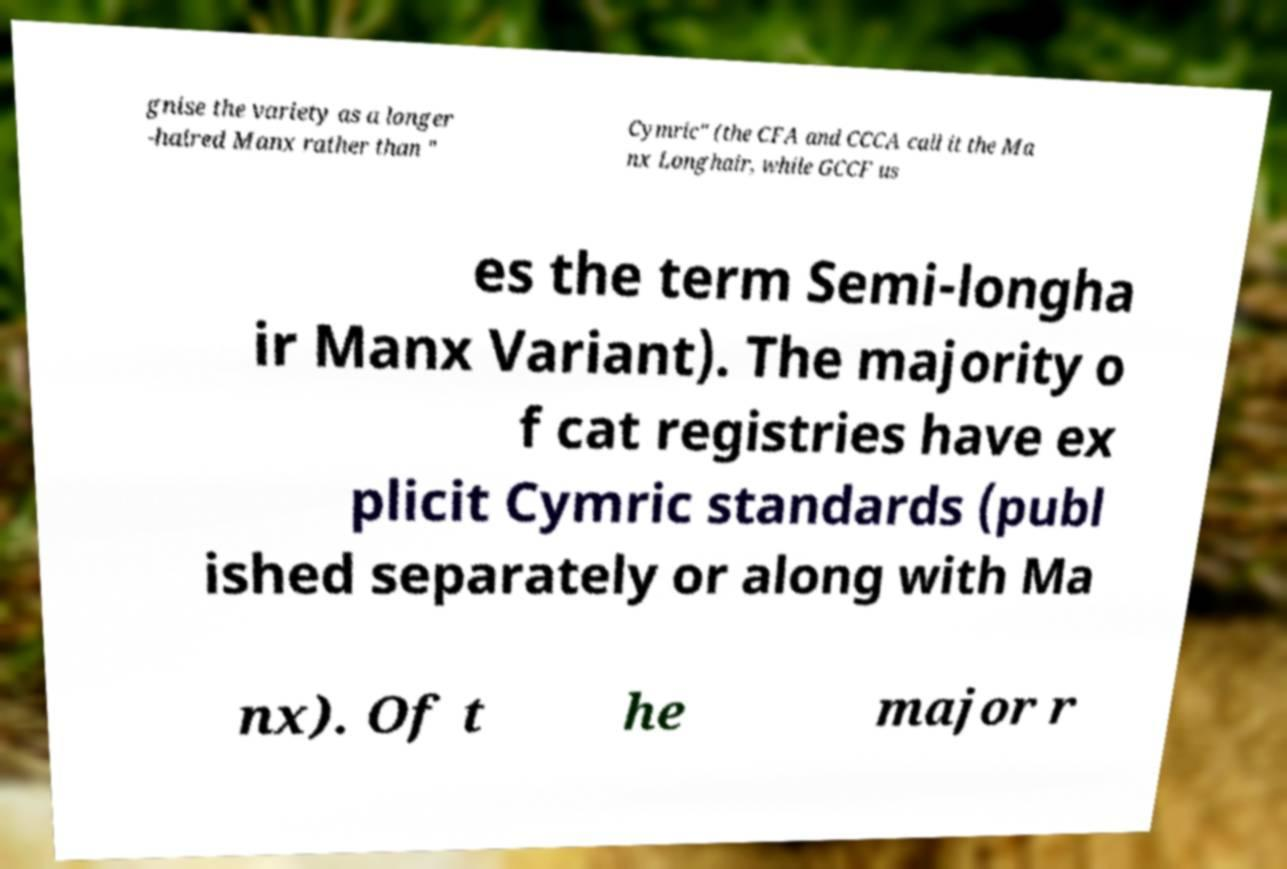I need the written content from this picture converted into text. Can you do that? gnise the variety as a longer -haired Manx rather than " Cymric" (the CFA and CCCA call it the Ma nx Longhair, while GCCF us es the term Semi-longha ir Manx Variant). The majority o f cat registries have ex plicit Cymric standards (publ ished separately or along with Ma nx). Of t he major r 